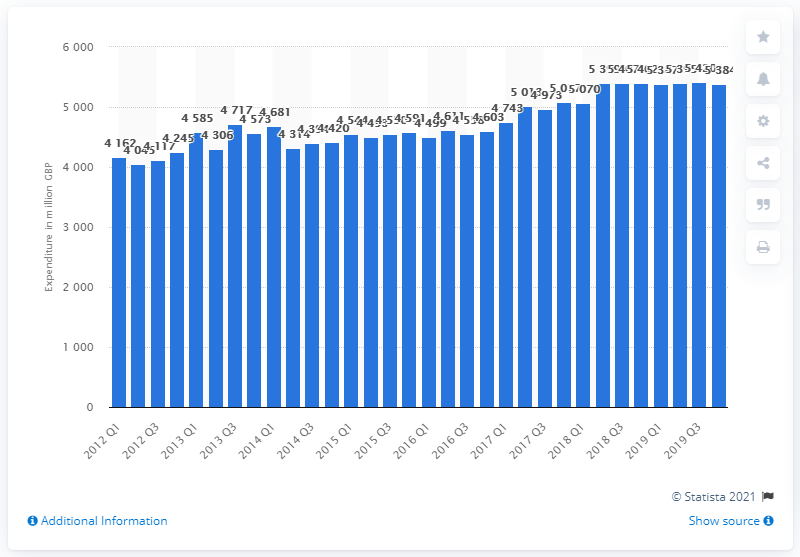Outline some significant characteristics in this image. In the fourth quarter of 2019, the total amount of consumer spending on alcohol in the UK was 5,384. 